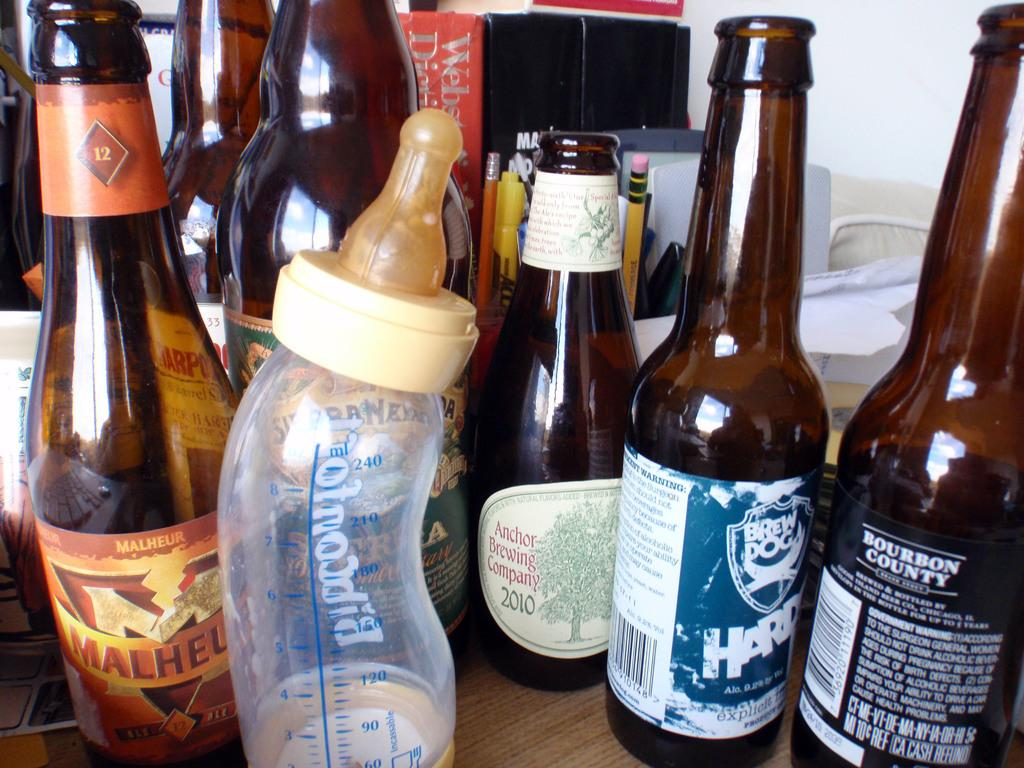What objects are visible in the image? There are bottles in the image. Where are the bottles located? The bottles are on a table. What type of shirt is the fly wearing in the image? There is no fly or shirt present in the image. 